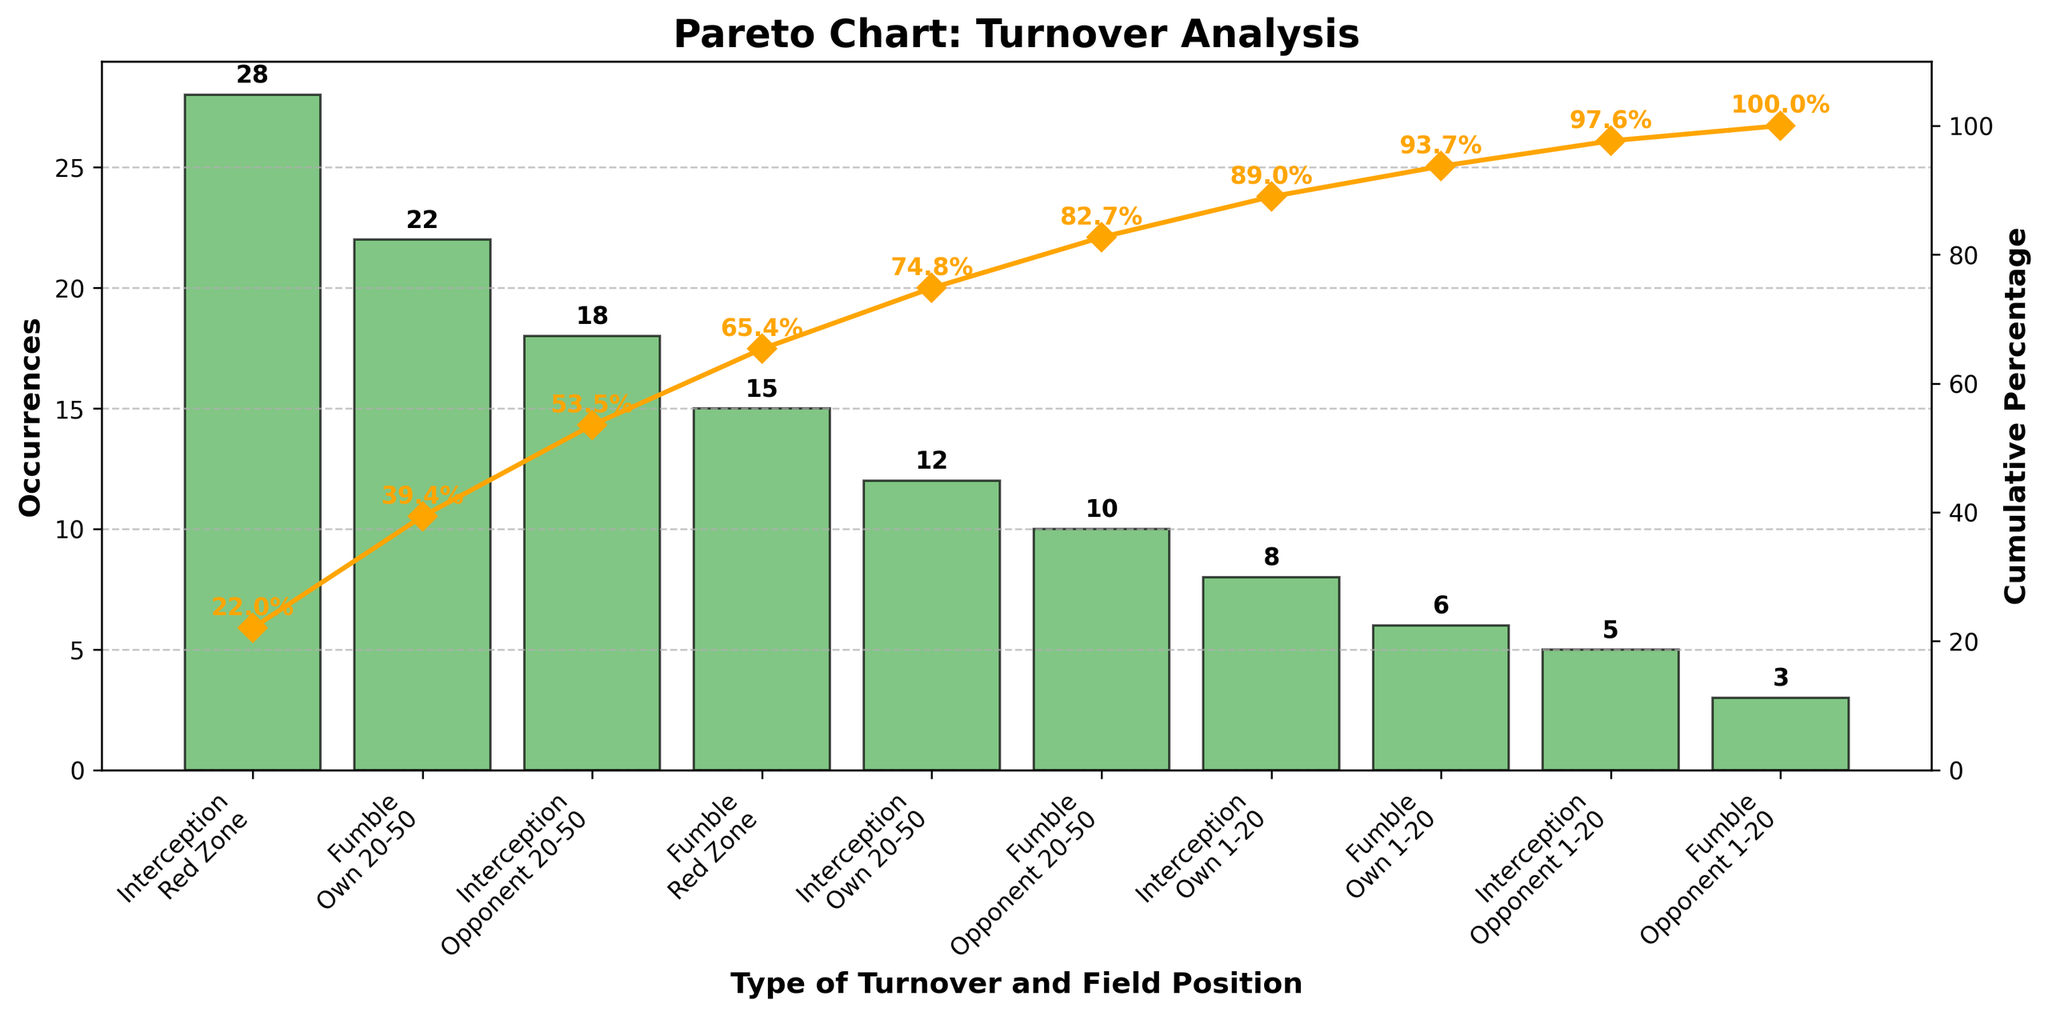What is the title of the figure? The title of a figure is typically found at the top and provides a summary of what the figure represents. In this figure, the title is bold and located at the top.
Answer: Pareto Chart: Turnover Analysis How many different types of turnovers are there? By examining the x-axis labels, we see various turnovers, such as Interception and Fumble, differentiated by field positions such as Red Zone and Own 20-50. Counting these unique types provides the answer.
Answer: 10 What color are the bars in the chart? The color of the bars can be described by their appearance. In this figure, the bars are in a shade of green.
Answer: Green Which type of turnover occurs the most frequently? To identify the turnover with the highest occurrences, look for the tallest bar in the bar chart. The label beneath this bar indicates the type.
Answer: Interception, Red Zone What is the cumulative percentage after three categories? The cumulative percentage line (orange line) indicates the cumulative total after each category. For the third category, find the point on the orange line and the corresponding y-axis value of the secondary axis.
Answer: 52.6% What is the total number of occurrences for turnovers in the Red Zone? Identify the bars labeled with "Red Zone" and sum their occurrences. Interception in Red Zone: 28, Fumble in Red Zone: 15. Total: 28 + 15 = 43
Answer: 43 Which type of turnover has the lowest occurrences, and how many are there? Look for the shortest bar in the chart, and note the label and occurrences number next to it.
Answer: Fumble, Opponent 1-20, 3 How many turnovers occurred in Own 20-50 for both types combined? Identify the bars corresponding to Own 20-50 for each turnover type (Fumble and Interception) and sum their occurrences. Fumble: 22, Interception: 12. Total: 22 + 12 = 34
Answer: 34 What is the percentage of total occurrences represented by the largest category? Find the largest category with the tallest bar (Interception, Red Zone) and refer to its cumulative percentage. Occurrences: 28 out of a total of 127. Percentage: (28/127) * 100 ≈ 22.0%
Answer: 22.0% Which two turnover types have the most similar occurrences, and what are they? Visually compare the heights of the bars to identify pairs with almost equal heights. Fumble Own 20-50 (22) and Interception Opponent 20-50 (18) are close.
Answer: Fumble, Own 20-50; Interception, Opponent 20-50 